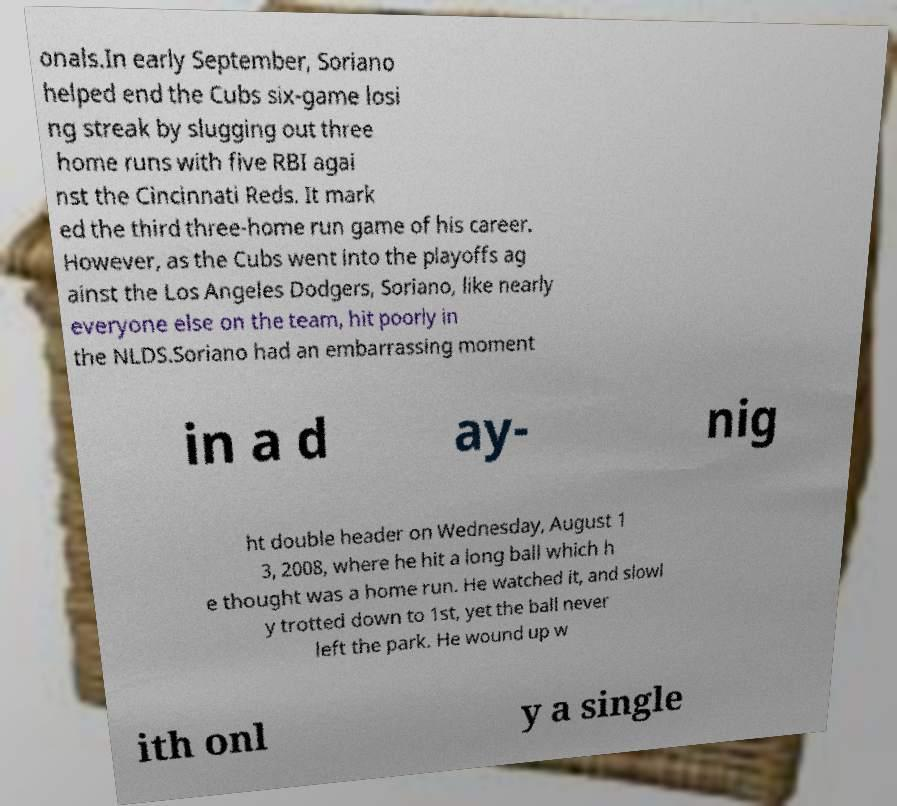There's text embedded in this image that I need extracted. Can you transcribe it verbatim? onals.In early September, Soriano helped end the Cubs six-game losi ng streak by slugging out three home runs with five RBI agai nst the Cincinnati Reds. It mark ed the third three-home run game of his career. However, as the Cubs went into the playoffs ag ainst the Los Angeles Dodgers, Soriano, like nearly everyone else on the team, hit poorly in the NLDS.Soriano had an embarrassing moment in a d ay- nig ht double header on Wednesday, August 1 3, 2008, where he hit a long ball which h e thought was a home run. He watched it, and slowl y trotted down to 1st, yet the ball never left the park. He wound up w ith onl y a single 